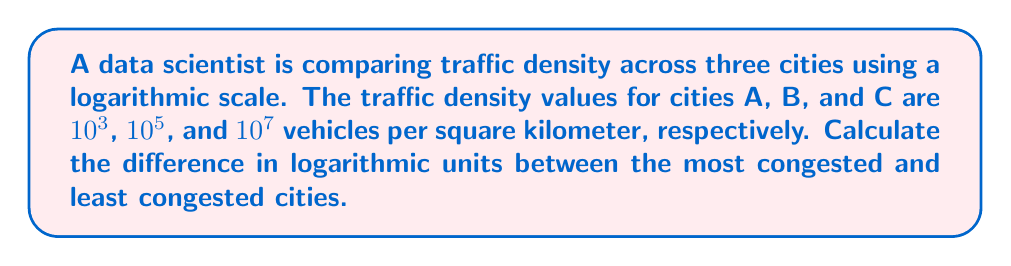Help me with this question. To solve this problem, we'll follow these steps:

1. Identify the most and least congested cities:
   - City A: $10^3$ vehicles/km²
   - City B: $10^5$ vehicles/km²
   - City C: $10^7$ vehicles/km²

   City C is the most congested, and City A is the least congested.

2. Convert the traffic density values to logarithmic scale:
   - For City A: $\log_{10}(10^3) = 3$
   - For City C: $\log_{10}(10^7) = 7$

3. Calculate the difference in logarithmic units:
   $$\text{Difference} = \log_{10}(10^7) - \log_{10}(10^3) = 7 - 3 = 4$$

This result means that the traffic density in City C is 10,000 times (10^4) greater than in City A, as:

$$10^4 = 10^{7-3} = \frac{10^7}{10^3}$$

The logarithmic scale allows for easy comparison of values that span several orders of magnitude, which is particularly useful in analyzing traffic density across different urban areas.
Answer: 4 logarithmic units 